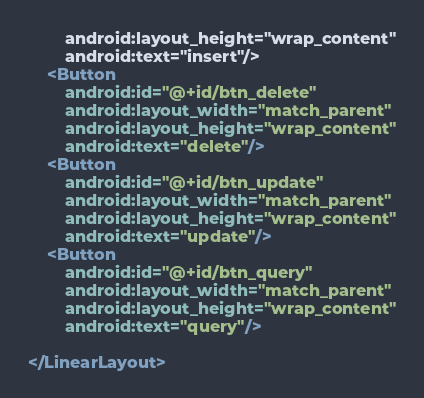<code> <loc_0><loc_0><loc_500><loc_500><_XML_>        android:layout_height="wrap_content"
        android:text="insert"/>
    <Button
        android:id="@+id/btn_delete"
        android:layout_width="match_parent"
        android:layout_height="wrap_content"
        android:text="delete"/>
    <Button
        android:id="@+id/btn_update"
        android:layout_width="match_parent"
        android:layout_height="wrap_content"
        android:text="update"/>
    <Button
        android:id="@+id/btn_query"
        android:layout_width="match_parent"
        android:layout_height="wrap_content"
        android:text="query"/>

</LinearLayout>
</code> 